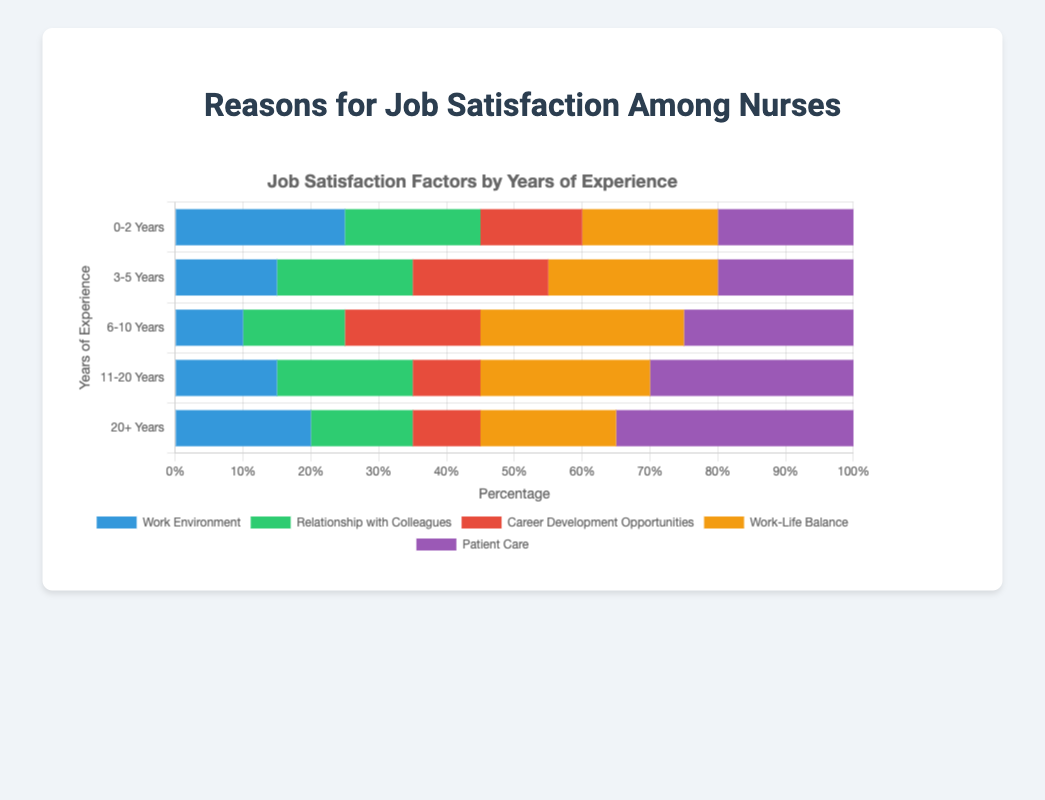How does the importance of 'Work Environment' change as experience increases? To answer this, observe the bars for 'Work Environment' across each of the experience categories. The percentages for 'Work Environment' are: 25% (0-2 Years), 15% (3-5 Years), 10% (6-10 Years), 15% (11-20 Years), and 20% (20+ Years). Initially, it decreases up to 6-10 years and then increases again for more experienced categories.
Answer: It decreases initially, then increases Which category values 'Patient Care' the most? Look for the bar corresponding to 'Patient Care' across all experience categories and identify the highest percentage. The highest percentage for 'Patient Care' is in the '20+ Years' group with 35%.
Answer: '20+ Years' Which reason has the lowest percentage for nurses with 6-10 years of experience? Identify the lowest bar within the '6-10 Years' category. 'Work Environment' has the lowest percentage, at 10%.
Answer: 'Work Environment' What is the sum of percentages for 'Career Development Opportunities' and 'Work-Life Balance' for nurses with 3-5 years of experience? Add the percentages for 'Career Development Opportunities' (20%) and 'Work-Life Balance' (25%) in the '3-5 Years' category. 20% + 25% = 45%.
Answer: 45% How does the 'Relationship with Colleagues' change from 0-2 years to 6-10 years of experience? Compare the percentages of 'Relationship with Colleagues' between '0-2 Years' (20%), '3-5 Years' (20%), and '6-10 Years' (15%). It remains constant from 0-2 to 3-5 years but decreases to 15% at 6-10 years.
Answer: Decreases by 5% What trend can you observe for 'Work-Life Balance' across different experience categories? Starting at 20% (0-2 Years), 'Work-Life Balance' increases to 25% (3-5 Years), 30% (6-10 Years), stays at 25% (11-20 Years), and ends at 20% (20+ Years). There is an increase up to 6-10 years, followed by a decrease.
Answer: Increases, then decreases Which factors are equally important for nurses with 0-2 years of experience? Observe the bars for the '0-2 Years' category and identify equal values. 'Relationship with Colleagues', 'Work-Life Balance', and 'Patient Care' all have 20%.
Answer: 'Relationship with Colleagues', 'Work-Life Balance', 'Patient Care' What is the average percentage for 'Career Development Opportunities' across all categories? Calculate the average by adding the percentages for 'Career Development Opportunities' across all categories and dividing by the number of categories: (15% + 20% + 20% + 10% + 10%) / 5. Sum = 75%, Average = 75% / 5 = 15%.
Answer: 15% Which reason has the highest percentage overall for nurses with 11-20 years of experience? Identify the highest bar within the '11-20 Years' category. 'Patient Care' has the highest percentage at 30%.
Answer: 'Patient Care' 